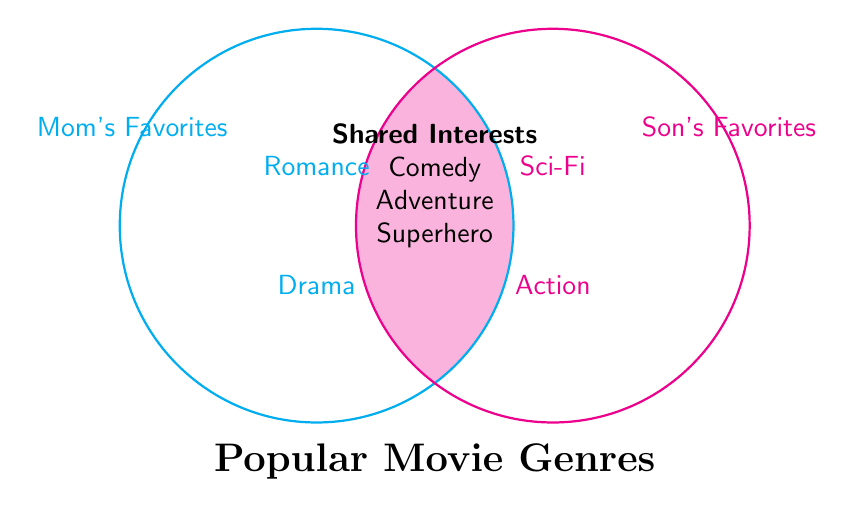Which genres are liked by both you and your son? The genres listed in the overlapping part of the Venn Diagram are Comedy, Adventure, and Superhero, indicating mutual interests.
Answer: Comedy, Adventure, Superhero What genres does your son like that you don't? The genres listed only in the "Son's Favorites" circle are Action and Sci-Fi, which are not in the "Mom's Favorites" circle.
Answer: Action, Sci-Fi How many genres are shared? Count the genres in the overlapping section where "Mom's Favorites" and "Son's Favorites" intersect: Comedy, Adventure, and Superhero.
Answer: 3 List your favorite genres that your son doesn't share. Identify genres only in the "Mom's Favorites" section which are Drama and Romance.
Answer: Drama, Romance Which genre categories have more than one genre listed? Look at both circles and their overlap: "Mom's Favorites" (Drama, Romance), "Son's Favorites" (Action, Sci-Fi), and "Shared Interests" (Comedy, Adventure, Superhero) all have more than one genre.
Answer: All categories What is the unique genre liked by your son? From "Son's Favorites" circle only when removing those in the overlapping section: Action, Sci-Fi. Both are unique to your son.
Answer: Action, Sci-Fi Do you have more unique genres than your son? Compare the number of genres unique to "Mom's Favorites" (2 genres: Drama, Romance) and "Son's Favorites" (2 genres: Action, Sci-Fi).
Answer: No Total genres listed in the Venn Diagram? Count all the unique genres across "Mom's Favorites", "Son's Favorites", and the overlapping section: Drama, Romance, Action, Sci-Fi, Comedy, Adventure, Superhero.
Answer: 7 Which genre categories include 'Superhero'? Refer to the overlapping section where the genres are shared between both Venn circles, indicating "Shared Interests."
Answer: Shared Which category is 'Adventure' listed under? Find 'Adventure' mentioned, it is in the overlapping section where both categories share interests.
Answer: Shared 